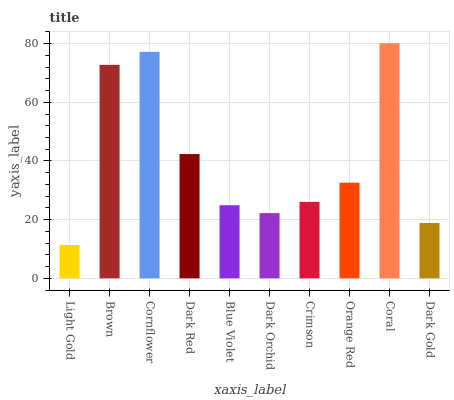Is Light Gold the minimum?
Answer yes or no. Yes. Is Coral the maximum?
Answer yes or no. Yes. Is Brown the minimum?
Answer yes or no. No. Is Brown the maximum?
Answer yes or no. No. Is Brown greater than Light Gold?
Answer yes or no. Yes. Is Light Gold less than Brown?
Answer yes or no. Yes. Is Light Gold greater than Brown?
Answer yes or no. No. Is Brown less than Light Gold?
Answer yes or no. No. Is Orange Red the high median?
Answer yes or no. Yes. Is Crimson the low median?
Answer yes or no. Yes. Is Coral the high median?
Answer yes or no. No. Is Brown the low median?
Answer yes or no. No. 